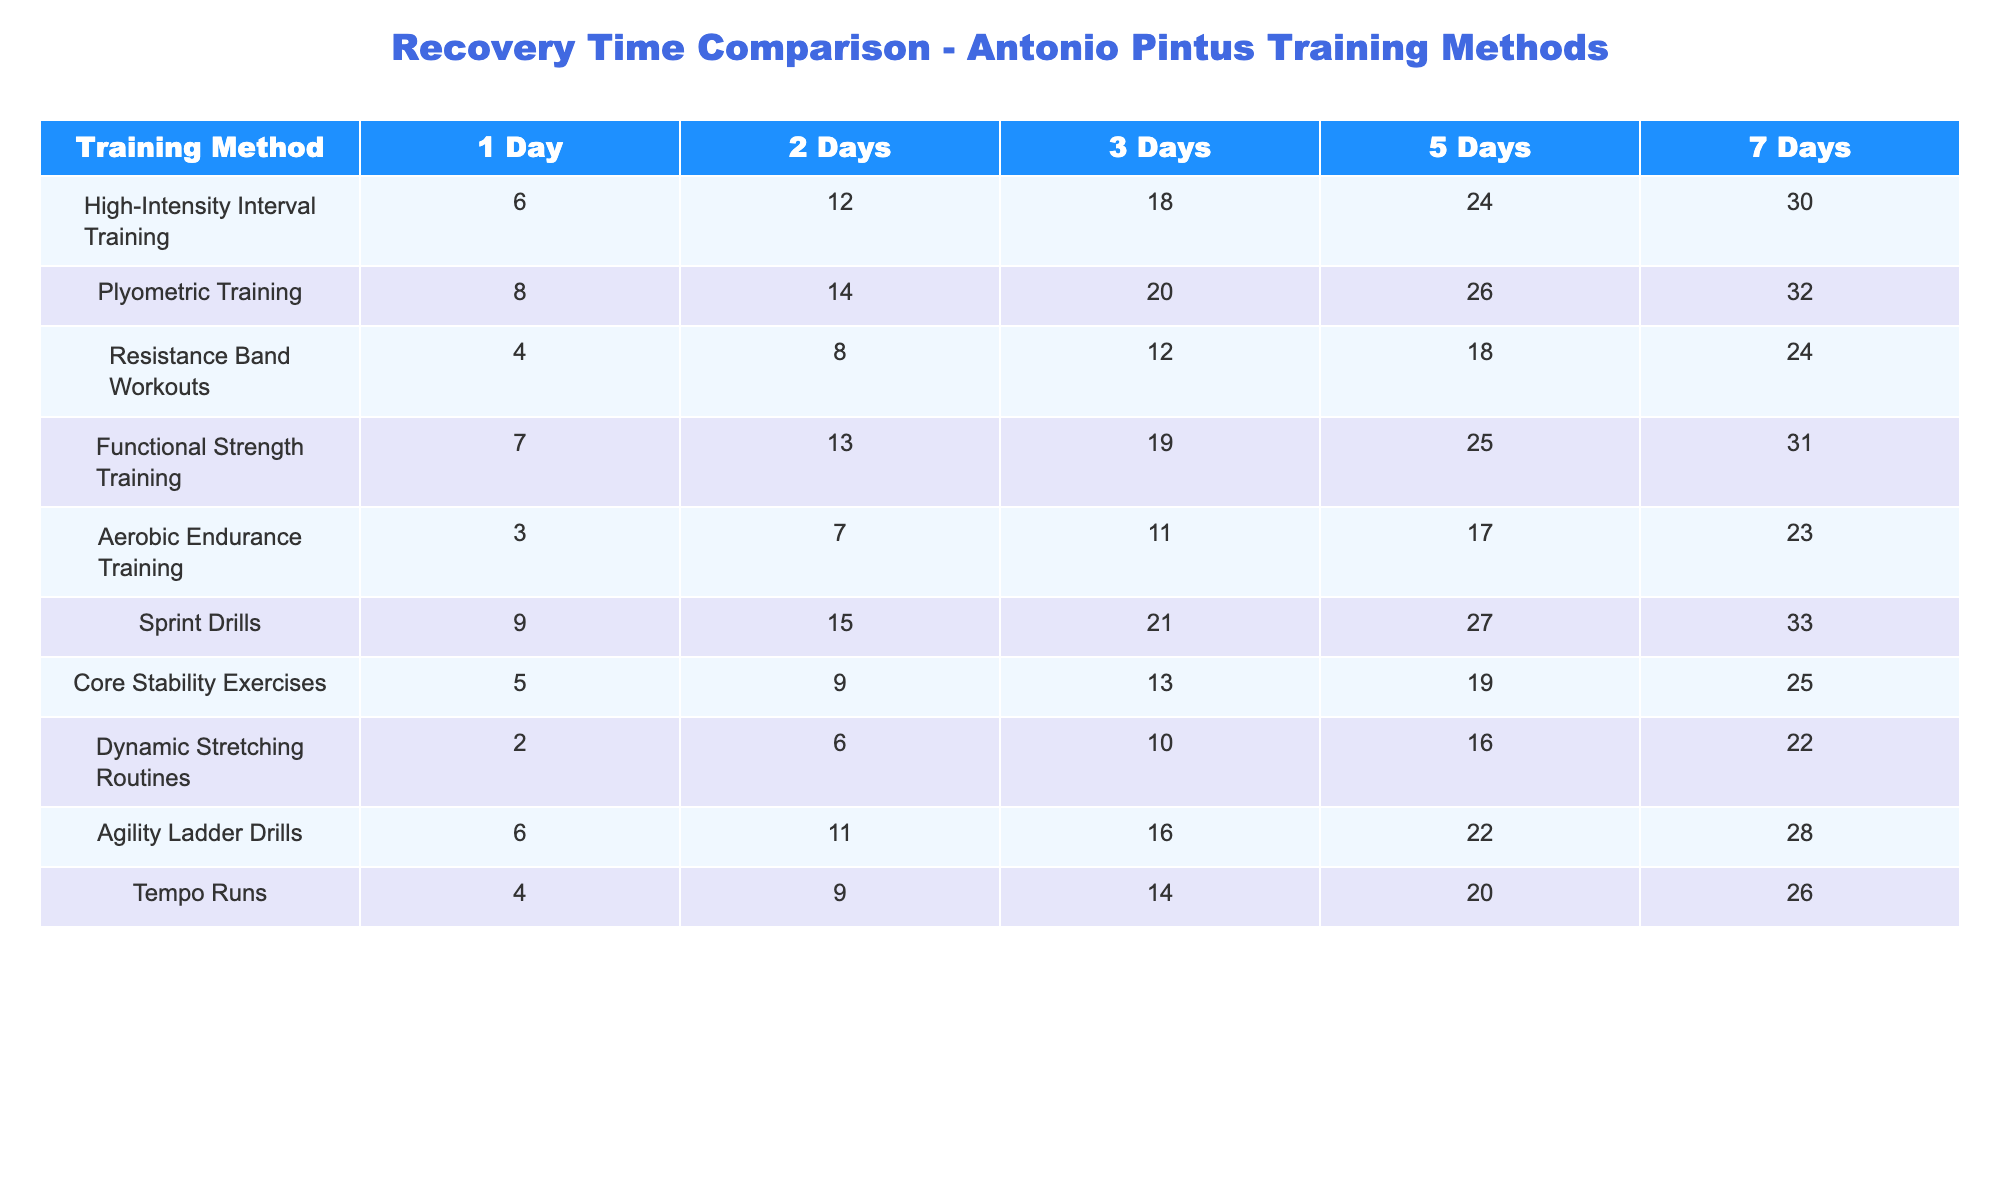What is the recovery time for High-Intensity Interval Training after 3 days? The table shows that the recovery time for High-Intensity Interval Training after 3 days is listed as 18.
Answer: 18 Which training method has the shortest recovery time after 1 day? Looking at the first column of the table, Aerobic Endurance Training has the shortest recovery time of 3 after 1 day.
Answer: 3 What is the difference in recovery time between Plyometric Training and Resistance Band Workouts after 5 days? The recovery time for Plyometric Training after 5 days is 26, and for Resistance Band Workouts, it is 18. The difference is 26 - 18 = 8.
Answer: 8 Is the recovery time after 2 days for Sprint Drills greater than that for Agility Ladder Drills? The recovery time for Sprint Drills after 2 days is 15, while for Agility Ladder Drills, it is 11. Since 15 is greater than 11, the answer is yes.
Answer: Yes What is the average recovery time after 7 days for all training methods listed? First, sum up the recovery times: 30 (HIIT) + 32 (Plyometrics) + 24 (Resistance Bands) + 31 (Strength) + 23 (Aerobic) + 33 (Sprint) + 25 (Core) + 22 (Dynamic) + 28 (Agility) + 26 (Tempo) =  309. Since there are 10 methods, divide by 10 for the average: 309 / 10 = 30.9.
Answer: 30.9 Which training method requires the longest recovery time after 1 day? By reviewing the first column, Sprint Drills have the longest recovery time of 9 after 1 day.
Answer: 9 What is the recovery time trend for Aerobic Endurance Training over the 5 different durations? The recovery times increase consistently from 3 (1 day) to 23 (7 days). This shows a clear upward trend.
Answer: Increasing trend Calculate the total recovery time for Core Stability Exercises over 3 days. The recovery time for Core Stability Exercises after 1 day is 5, after 2 days is 9, and after 3 days is 13. Total recovery time = 5 + 9 + 13 = 27.
Answer: 27 Is the average recovery time after 5 days for Resistance Band Workouts higher than for Dynamic Stretching Routines? Resistance Band Workouts have a recovery time of 18 and Dynamic Stretching Routines have 16 after 5 days. Thus, the average for Resistance Band Workouts (18) is higher than that of Dynamic Stretching Routines (16).
Answer: Yes What is the recovery time for Tempo Runs after 2 days? According to the table, the recovery time for Tempo Runs after 2 days is 9.
Answer: 9 How much more recovery time is needed for Sprint Drills compared to Core Stability Exercises after 5 days? Sprint Drills have a recovery time of 27 while Core Stability Exercises have 19 after 5 days. The difference is 27 - 19 = 8.
Answer: 8 